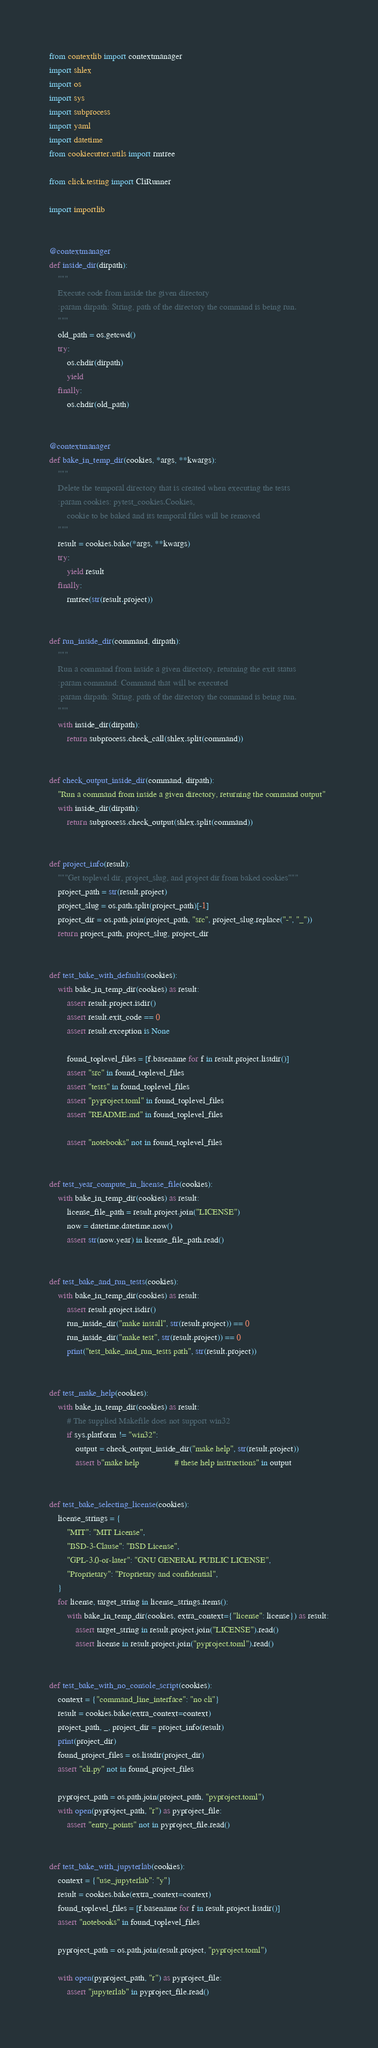<code> <loc_0><loc_0><loc_500><loc_500><_Python_>from contextlib import contextmanager
import shlex
import os
import sys
import subprocess
import yaml
import datetime
from cookiecutter.utils import rmtree

from click.testing import CliRunner

import importlib


@contextmanager
def inside_dir(dirpath):
    """
    Execute code from inside the given directory
    :param dirpath: String, path of the directory the command is being run.
    """
    old_path = os.getcwd()
    try:
        os.chdir(dirpath)
        yield
    finally:
        os.chdir(old_path)


@contextmanager
def bake_in_temp_dir(cookies, *args, **kwargs):
    """
    Delete the temporal directory that is created when executing the tests
    :param cookies: pytest_cookies.Cookies,
        cookie to be baked and its temporal files will be removed
    """
    result = cookies.bake(*args, **kwargs)
    try:
        yield result
    finally:
        rmtree(str(result.project))


def run_inside_dir(command, dirpath):
    """
    Run a command from inside a given directory, returning the exit status
    :param command: Command that will be executed
    :param dirpath: String, path of the directory the command is being run.
    """
    with inside_dir(dirpath):
        return subprocess.check_call(shlex.split(command))


def check_output_inside_dir(command, dirpath):
    "Run a command from inside a given directory, returning the command output"
    with inside_dir(dirpath):
        return subprocess.check_output(shlex.split(command))


def project_info(result):
    """Get toplevel dir, project_slug, and project dir from baked cookies"""
    project_path = str(result.project)
    project_slug = os.path.split(project_path)[-1]
    project_dir = os.path.join(project_path, "src", project_slug.replace("-", "_"))
    return project_path, project_slug, project_dir


def test_bake_with_defaults(cookies):
    with bake_in_temp_dir(cookies) as result:
        assert result.project.isdir()
        assert result.exit_code == 0
        assert result.exception is None

        found_toplevel_files = [f.basename for f in result.project.listdir()]
        assert "src" in found_toplevel_files
        assert "tests" in found_toplevel_files
        assert "pyproject.toml" in found_toplevel_files
        assert "README.md" in found_toplevel_files

        assert "notebooks" not in found_toplevel_files


def test_year_compute_in_license_file(cookies):
    with bake_in_temp_dir(cookies) as result:
        license_file_path = result.project.join("LICENSE")
        now = datetime.datetime.now()
        assert str(now.year) in license_file_path.read()


def test_bake_and_run_tests(cookies):
    with bake_in_temp_dir(cookies) as result:
        assert result.project.isdir()
        run_inside_dir("make install", str(result.project)) == 0
        run_inside_dir("make test", str(result.project)) == 0
        print("test_bake_and_run_tests path", str(result.project))


def test_make_help(cookies):
    with bake_in_temp_dir(cookies) as result:
        # The supplied Makefile does not support win32
        if sys.platform != "win32":
            output = check_output_inside_dir("make help", str(result.project))
            assert b"make help                # these help instructions" in output


def test_bake_selecting_license(cookies):
    license_strings = {
        "MIT": "MIT License",
        "BSD-3-Clause": "BSD License",
        "GPL-3.0-or-later": "GNU GENERAL PUBLIC LICENSE",
        "Proprietary": "Proprietary and confidential",
    }
    for license, target_string in license_strings.items():
        with bake_in_temp_dir(cookies, extra_context={"license": license}) as result:
            assert target_string in result.project.join("LICENSE").read()
            assert license in result.project.join("pyproject.toml").read()


def test_bake_with_no_console_script(cookies):
    context = {"command_line_interface": "no cli"}
    result = cookies.bake(extra_context=context)
    project_path, _, project_dir = project_info(result)
    print(project_dir)
    found_project_files = os.listdir(project_dir)
    assert "cli.py" not in found_project_files

    pyproject_path = os.path.join(project_path, "pyproject.toml")
    with open(pyproject_path, "r") as pyproject_file:
        assert "entry_points" not in pyproject_file.read()


def test_bake_with_jupyterlab(cookies):
    context = {"use_jupyterlab": "y"}
    result = cookies.bake(extra_context=context)
    found_toplevel_files = [f.basename for f in result.project.listdir()]
    assert "notebooks" in found_toplevel_files

    pyproject_path = os.path.join(result.project, "pyproject.toml")

    with open(pyproject_path, "r") as pyproject_file:
        assert "jupyterlab" in pyproject_file.read()
</code> 